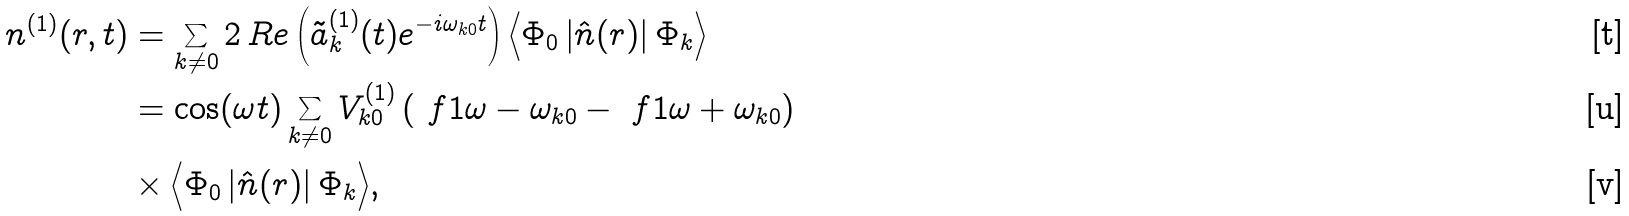Convert formula to latex. <formula><loc_0><loc_0><loc_500><loc_500>n ^ { ( 1 ) } ( r , t ) & = \sum _ { k \neq 0 } 2 \, R e \left ( \tilde { a } _ { k } ^ { ( 1 ) } ( t ) e ^ { - i \omega _ { k 0 } t } \right ) \Big < \Phi _ { 0 } \left | \hat { n } ( r ) \right | \Phi _ { k } \Big > \\ & = \cos ( \omega t ) \sum _ { k \neq 0 } V _ { k 0 } ^ { ( 1 ) } \left ( \ f { 1 } { \omega - \omega _ { k 0 } } - \ f { 1 } { \omega + \omega _ { k 0 } } \right ) \\ & \times \Big < \Phi _ { 0 } \left | \hat { n } ( r ) \right | \Phi _ { k } \Big > ,</formula> 